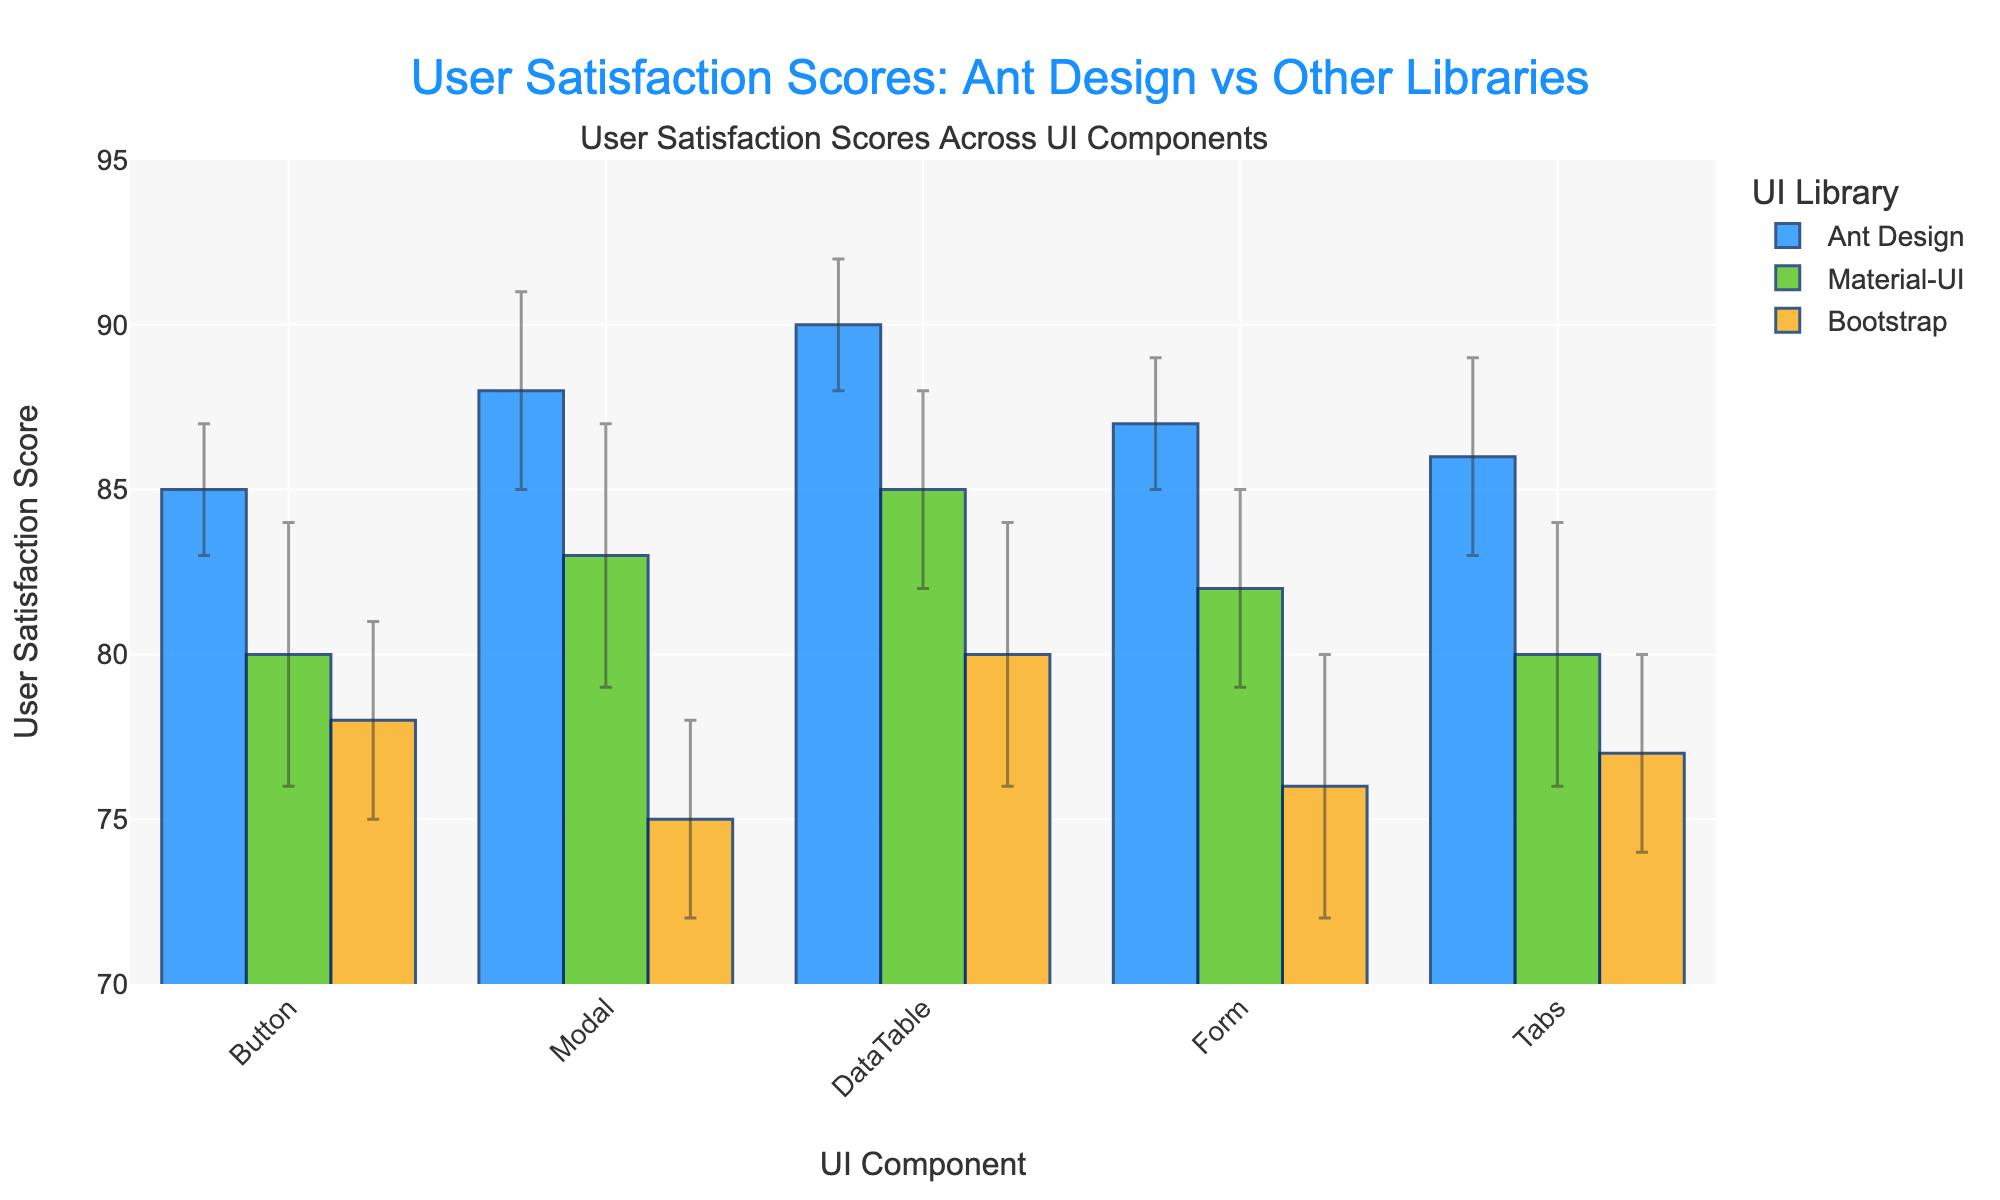What is the user satisfaction score for the Ant Design DataTable component? The bar for the Ant Design DataTable component is clearly labeled with a user satisfaction score of 90 with an error of 2.
Answer: 90 Which UI library has the highest average user satisfaction score across all components? Calculate the average score for each library: Ant Design (87.2), Material-UI (82), Bootstrap (77.2). Ant Design has the highest average.
Answer: Ant Design What is the difference in user satisfaction scores between the Ant Design and Bootstrap Form components? The score for Ant Design Form is 87, and for Bootstrap Form, it is 76. The difference is 87 - 76 = 11.
Answer: 11 Which component has the smallest error bar for the Ant Design library? The Bars representing Ant Design components show that the error bar is smallest for the Ant Design DataTable and Button components, both with an error of 2.
Answer: DataTable or Button For which component does Material-UI have a user satisfaction score closest to that of Ant Design? By looking at the user satisfaction scores, the Material-UI DataTable (85) has a score closest to Ant Design DataTable (90), with a difference of 5.
Answer: DataTable Which component has the largest difference in user satisfaction scores between Ant Design and Material-UI? Calculate the differences: Button (85-80=5), Modal (88-83=5), DataTable (90-85=5), Form (87-82=5), Tabs (86-80=6). Thus, Tabs has the largest difference.
Answer: Tabs What is the range of user satisfaction scores for the UI libraries across all components? Scores range from the lowest (75 for Bootstrap Modal) to the highest (90 for Ant Design DataTable), so the range is 90 - 75 = 15.
Answer: 15 